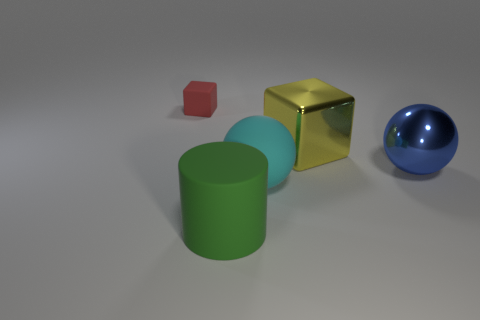Are there any large cubes that have the same color as the rubber sphere?
Offer a terse response. No. There is another metal thing that is the same size as the yellow object; what is its shape?
Your response must be concise. Sphere. There is a cube that is left of the big yellow thing; does it have the same color as the metallic block?
Offer a very short reply. No. What number of objects are either big green matte cylinders that are on the left side of the blue shiny thing or balls?
Your answer should be very brief. 3. Is the number of cyan objects that are in front of the rubber cylinder greater than the number of cyan matte things behind the big cyan rubber thing?
Your answer should be compact. No. Do the large yellow cube and the red thing have the same material?
Ensure brevity in your answer.  No. What is the shape of the big thing that is both left of the large yellow object and to the right of the green matte thing?
Provide a succinct answer. Sphere. There is a big thing that is the same material as the large yellow block; what shape is it?
Ensure brevity in your answer.  Sphere. Are there any large blue shiny balls?
Your answer should be very brief. Yes. Are there any cylinders behind the cube on the right side of the small red object?
Offer a terse response. No. 